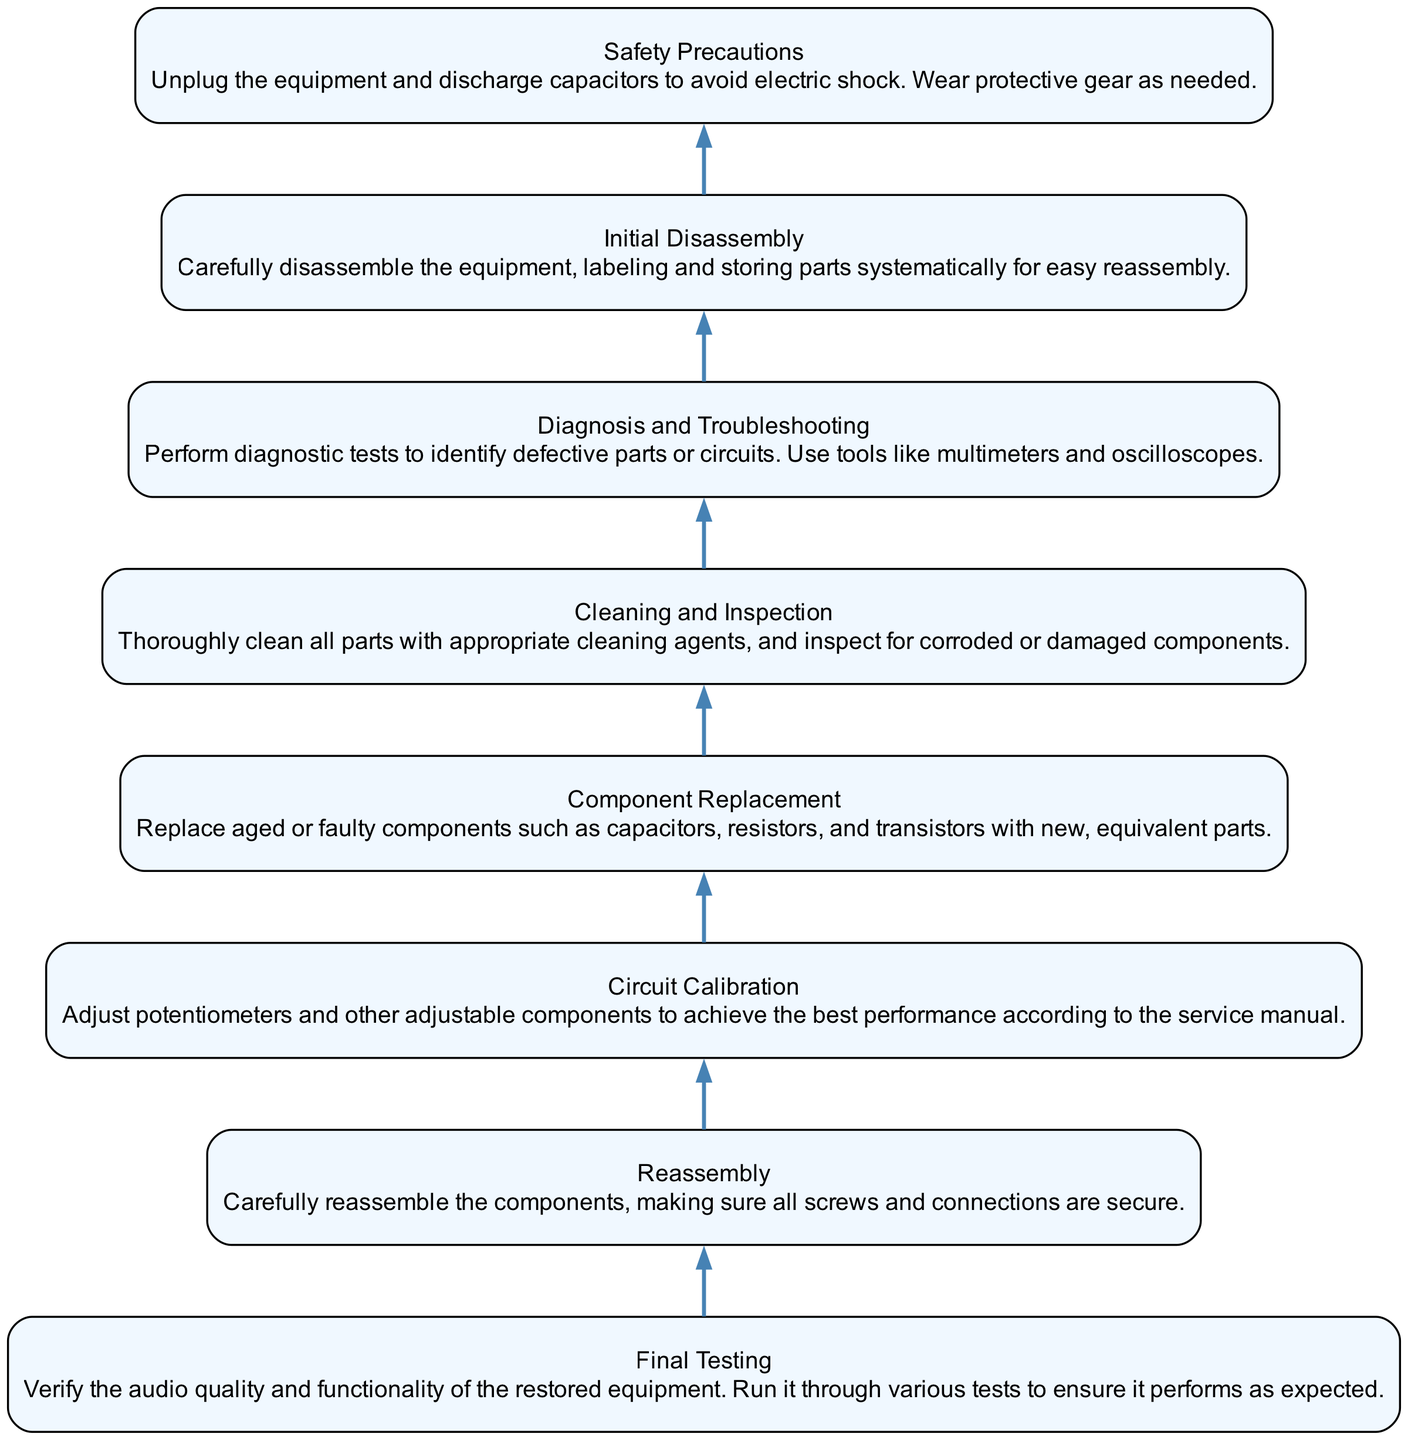What is the first step in the restoration process? The restoration process starts with the "Safety Precautions" step, which involves unplugging the equipment and discharging capacitors.
Answer: Safety Precautions How many total steps are there in the diagram? There are eight distinct steps shown in the diagram, from "Safety Precautions" to "Final Testing."
Answer: Eight Which step comes immediately after "Initial Disassembly"? The step that follows "Initial Disassembly" is "Cleaning and Inspection," indicating the process of cleaning parts after they have been taken apart.
Answer: Cleaning and Inspection What icon is used for the "Diagnosis and Troubleshooting" step? The icon for "Diagnosis and Troubleshooting" is the "multimeter," suggesting the importance of diagnostic tools in this step.
Answer: multimeter Which steps involve component replacement or adjustment? The steps that involve replacing or adjusting components are "Component Replacement" and "Circuit Calibration," as both focus on improving the functionality of the equipment.
Answer: Component Replacement, Circuit Calibration How does the "Reassembly" step relate to "Final Testing"? The "Reassembly" step occurs directly before "Final Testing," indicating that after components are put back together, the final tests on the equipment's performance are conducted.
Answer: Reassembly If a problem is found during "Diagnosis and Troubleshooting," which step should be revisited? If issues are detected during "Diagnosis and Troubleshooting," the "Component Replacement" step should be revisited to replace any faulty components identified.
Answer: Component Replacement What action is emphasized in the "Cleaning and Inspection" step? The main action in "Cleaning and Inspection" is to thoroughly clean all parts and check for any corroded or damaged components, ensuring everything is in good condition before further steps.
Answer: Clean and inspect components 